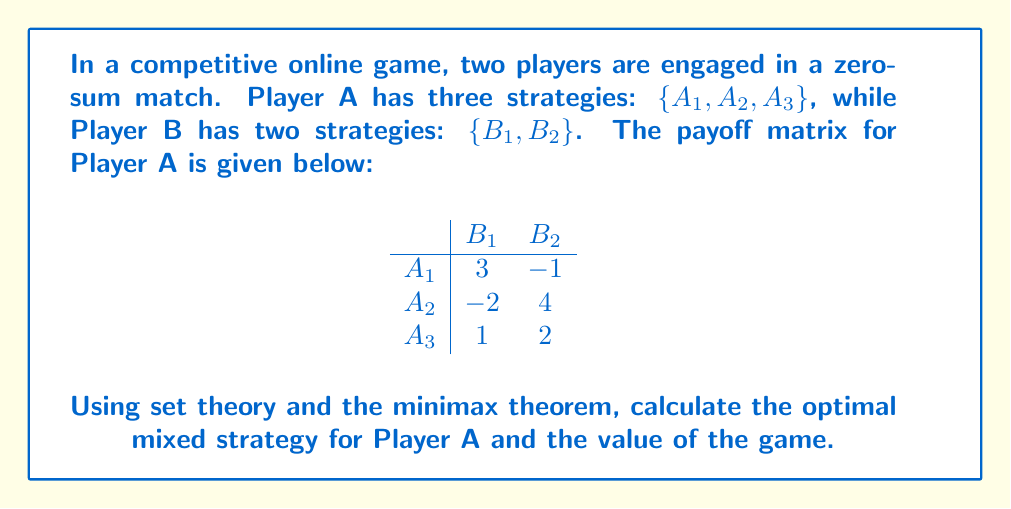Help me with this question. To solve this problem, we'll use the minimax theorem and set theory concepts:

1) First, let's define the set of pure strategies for each player:
   $S_A = \{A_1, A_2, A_3\}$, $S_B = \{B_1, B_2\}$

2) The set of mixed strategies for Player A is:
   $X = \{(x_1, x_2, x_3) | x_1 + x_2 + x_3 = 1, x_i \geq 0\}$

3) For Player B:
   $Y = \{(y_1, y_2) | y_1 + y_2 = 1, y_i \geq 0\}$

4) The expected payoff function is:
   $E(x,y) = 3x_1y_1 - x_1y_2 - 2x_2y_1 + 4x_2y_2 + x_3y_1 + 2x_3y_2$

5) According to the minimax theorem, we need to find:
   $\max_{x \in X} \min_{y \in Y} E(x,y) = \min_{y \in Y} \max_{x \in X} E(x,y)$

6) To solve this, we set up the linear program:
   Maximize $v$
   Subject to:
   $3x_1 - 2x_2 + x_3 \geq v$
   $-x_1 + 4x_2 + 2x_3 \geq v$
   $x_1 + x_2 + x_3 = 1$
   $x_1, x_2, x_3 \geq 0$

7) Solving this linear program (using simplex method or software), we get:
   $x_1 = \frac{3}{7}, x_2 = \frac{2}{7}, x_3 = \frac{2}{7}$
   $v = \frac{11}{7}$

8) Therefore, the optimal mixed strategy for Player A is $(\frac{3}{7}, \frac{2}{7}, \frac{2}{7})$, and the value of the game is $\frac{11}{7}$.
Answer: Optimal strategy: $(\frac{3}{7}, \frac{2}{7}, \frac{2}{7})$; Game value: $\frac{11}{7}$ 